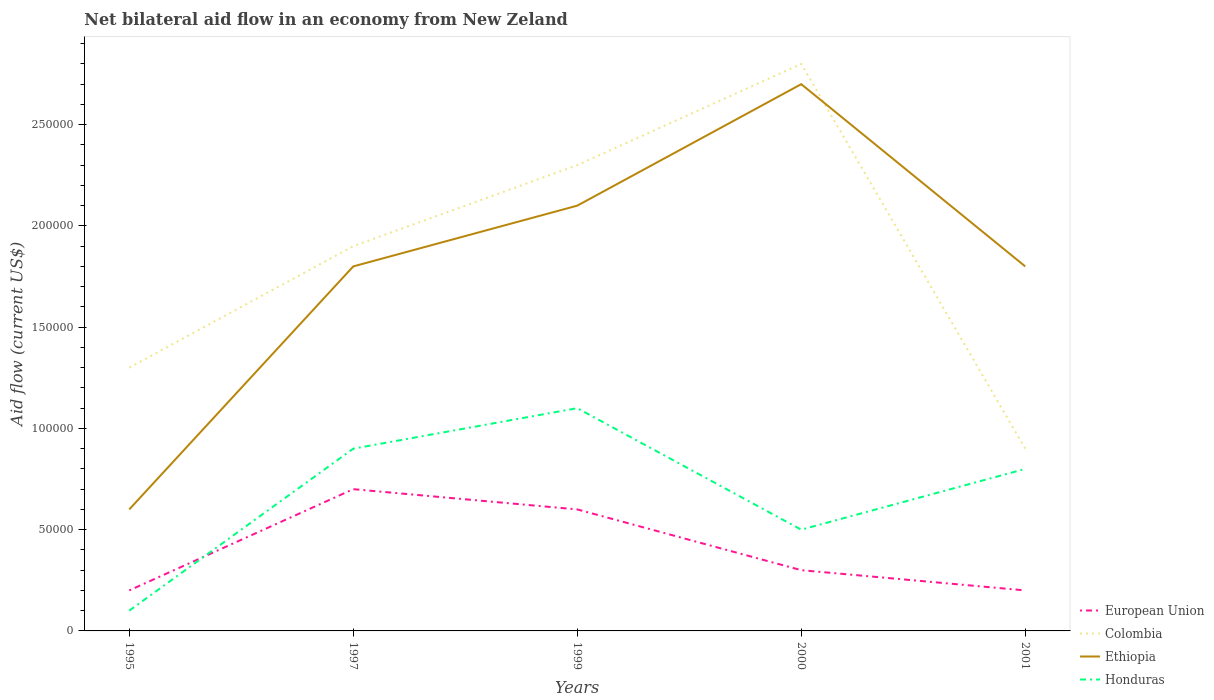What is the difference between the highest and the lowest net bilateral aid flow in Colombia?
Make the answer very short. 3. Is the net bilateral aid flow in Colombia strictly greater than the net bilateral aid flow in European Union over the years?
Your answer should be very brief. No. What is the difference between two consecutive major ticks on the Y-axis?
Keep it short and to the point. 5.00e+04. Does the graph contain any zero values?
Make the answer very short. No. What is the title of the graph?
Your answer should be very brief. Net bilateral aid flow in an economy from New Zeland. Does "Tunisia" appear as one of the legend labels in the graph?
Ensure brevity in your answer.  No. What is the label or title of the Y-axis?
Offer a terse response. Aid flow (current US$). What is the Aid flow (current US$) in European Union in 1995?
Offer a terse response. 2.00e+04. What is the Aid flow (current US$) of Colombia in 1995?
Offer a very short reply. 1.30e+05. What is the Aid flow (current US$) in Ethiopia in 1995?
Keep it short and to the point. 6.00e+04. What is the Aid flow (current US$) in Honduras in 1997?
Offer a very short reply. 9.00e+04. What is the Aid flow (current US$) in Colombia in 1999?
Provide a short and direct response. 2.30e+05. What is the Aid flow (current US$) of Ethiopia in 1999?
Offer a very short reply. 2.10e+05. What is the Aid flow (current US$) in Ethiopia in 2000?
Ensure brevity in your answer.  2.70e+05. What is the Aid flow (current US$) of Honduras in 2000?
Provide a succinct answer. 5.00e+04. What is the Aid flow (current US$) in European Union in 2001?
Offer a terse response. 2.00e+04. Across all years, what is the maximum Aid flow (current US$) of Ethiopia?
Provide a succinct answer. 2.70e+05. Across all years, what is the maximum Aid flow (current US$) of Honduras?
Your answer should be compact. 1.10e+05. Across all years, what is the minimum Aid flow (current US$) of Ethiopia?
Your answer should be compact. 6.00e+04. What is the total Aid flow (current US$) in Colombia in the graph?
Ensure brevity in your answer.  9.20e+05. What is the difference between the Aid flow (current US$) of Ethiopia in 1995 and that in 1997?
Your answer should be very brief. -1.20e+05. What is the difference between the Aid flow (current US$) of Honduras in 1995 and that in 1997?
Keep it short and to the point. -8.00e+04. What is the difference between the Aid flow (current US$) of European Union in 1995 and that in 1999?
Give a very brief answer. -4.00e+04. What is the difference between the Aid flow (current US$) of Ethiopia in 1995 and that in 1999?
Make the answer very short. -1.50e+05. What is the difference between the Aid flow (current US$) in Colombia in 1995 and that in 2000?
Your answer should be very brief. -1.50e+05. What is the difference between the Aid flow (current US$) in Ethiopia in 1995 and that in 2000?
Provide a succinct answer. -2.10e+05. What is the difference between the Aid flow (current US$) of European Union in 1995 and that in 2001?
Provide a short and direct response. 0. What is the difference between the Aid flow (current US$) in Colombia in 1995 and that in 2001?
Your response must be concise. 4.00e+04. What is the difference between the Aid flow (current US$) in Honduras in 1997 and that in 1999?
Provide a short and direct response. -2.00e+04. What is the difference between the Aid flow (current US$) of European Union in 1997 and that in 2000?
Provide a succinct answer. 4.00e+04. What is the difference between the Aid flow (current US$) in Colombia in 1997 and that in 2000?
Give a very brief answer. -9.00e+04. What is the difference between the Aid flow (current US$) of Ethiopia in 1997 and that in 2000?
Keep it short and to the point. -9.00e+04. What is the difference between the Aid flow (current US$) in Honduras in 1997 and that in 2000?
Your answer should be very brief. 4.00e+04. What is the difference between the Aid flow (current US$) in Ethiopia in 1997 and that in 2001?
Provide a short and direct response. 0. What is the difference between the Aid flow (current US$) of European Union in 1999 and that in 2000?
Your answer should be compact. 3.00e+04. What is the difference between the Aid flow (current US$) in Colombia in 1999 and that in 2000?
Your answer should be very brief. -5.00e+04. What is the difference between the Aid flow (current US$) in Ethiopia in 1999 and that in 2000?
Give a very brief answer. -6.00e+04. What is the difference between the Aid flow (current US$) of Honduras in 1999 and that in 2000?
Your answer should be very brief. 6.00e+04. What is the difference between the Aid flow (current US$) of European Union in 1999 and that in 2001?
Your response must be concise. 4.00e+04. What is the difference between the Aid flow (current US$) in Colombia in 1999 and that in 2001?
Provide a short and direct response. 1.40e+05. What is the difference between the Aid flow (current US$) of Honduras in 1999 and that in 2001?
Make the answer very short. 3.00e+04. What is the difference between the Aid flow (current US$) of European Union in 2000 and that in 2001?
Offer a very short reply. 10000. What is the difference between the Aid flow (current US$) in Ethiopia in 2000 and that in 2001?
Your answer should be very brief. 9.00e+04. What is the difference between the Aid flow (current US$) in Honduras in 2000 and that in 2001?
Offer a terse response. -3.00e+04. What is the difference between the Aid flow (current US$) in European Union in 1995 and the Aid flow (current US$) in Colombia in 1997?
Keep it short and to the point. -1.70e+05. What is the difference between the Aid flow (current US$) of European Union in 1995 and the Aid flow (current US$) of Colombia in 1999?
Keep it short and to the point. -2.10e+05. What is the difference between the Aid flow (current US$) of European Union in 1995 and the Aid flow (current US$) of Honduras in 1999?
Provide a succinct answer. -9.00e+04. What is the difference between the Aid flow (current US$) in Colombia in 1995 and the Aid flow (current US$) in Ethiopia in 1999?
Keep it short and to the point. -8.00e+04. What is the difference between the Aid flow (current US$) in Ethiopia in 1995 and the Aid flow (current US$) in Honduras in 1999?
Offer a very short reply. -5.00e+04. What is the difference between the Aid flow (current US$) in European Union in 1995 and the Aid flow (current US$) in Ethiopia in 2000?
Give a very brief answer. -2.50e+05. What is the difference between the Aid flow (current US$) in Ethiopia in 1995 and the Aid flow (current US$) in Honduras in 2000?
Ensure brevity in your answer.  10000. What is the difference between the Aid flow (current US$) of European Union in 1995 and the Aid flow (current US$) of Colombia in 2001?
Your answer should be very brief. -7.00e+04. What is the difference between the Aid flow (current US$) of European Union in 1995 and the Aid flow (current US$) of Honduras in 2001?
Your response must be concise. -6.00e+04. What is the difference between the Aid flow (current US$) of Colombia in 1995 and the Aid flow (current US$) of Honduras in 2001?
Your answer should be compact. 5.00e+04. What is the difference between the Aid flow (current US$) of European Union in 1997 and the Aid flow (current US$) of Colombia in 1999?
Provide a succinct answer. -1.60e+05. What is the difference between the Aid flow (current US$) in European Union in 1997 and the Aid flow (current US$) in Ethiopia in 1999?
Your answer should be compact. -1.40e+05. What is the difference between the Aid flow (current US$) of Colombia in 1997 and the Aid flow (current US$) of Ethiopia in 1999?
Your answer should be compact. -2.00e+04. What is the difference between the Aid flow (current US$) in Colombia in 1997 and the Aid flow (current US$) in Honduras in 1999?
Provide a succinct answer. 8.00e+04. What is the difference between the Aid flow (current US$) of Ethiopia in 1997 and the Aid flow (current US$) of Honduras in 1999?
Keep it short and to the point. 7.00e+04. What is the difference between the Aid flow (current US$) in European Union in 1997 and the Aid flow (current US$) in Colombia in 2000?
Give a very brief answer. -2.10e+05. What is the difference between the Aid flow (current US$) in European Union in 1997 and the Aid flow (current US$) in Ethiopia in 2000?
Make the answer very short. -2.00e+05. What is the difference between the Aid flow (current US$) in European Union in 1997 and the Aid flow (current US$) in Honduras in 2000?
Offer a terse response. 2.00e+04. What is the difference between the Aid flow (current US$) in Colombia in 1997 and the Aid flow (current US$) in Ethiopia in 2000?
Your answer should be very brief. -8.00e+04. What is the difference between the Aid flow (current US$) in European Union in 1997 and the Aid flow (current US$) in Colombia in 2001?
Your answer should be very brief. -2.00e+04. What is the difference between the Aid flow (current US$) in European Union in 1997 and the Aid flow (current US$) in Ethiopia in 2001?
Your answer should be very brief. -1.10e+05. What is the difference between the Aid flow (current US$) of European Union in 1997 and the Aid flow (current US$) of Honduras in 2001?
Provide a succinct answer. -10000. What is the difference between the Aid flow (current US$) in Colombia in 1997 and the Aid flow (current US$) in Ethiopia in 2001?
Offer a very short reply. 10000. What is the difference between the Aid flow (current US$) in European Union in 1999 and the Aid flow (current US$) in Ethiopia in 2000?
Your answer should be compact. -2.10e+05. What is the difference between the Aid flow (current US$) in European Union in 1999 and the Aid flow (current US$) in Honduras in 2000?
Provide a succinct answer. 10000. What is the difference between the Aid flow (current US$) in Colombia in 1999 and the Aid flow (current US$) in Honduras in 2000?
Your answer should be compact. 1.80e+05. What is the difference between the Aid flow (current US$) of European Union in 1999 and the Aid flow (current US$) of Honduras in 2001?
Keep it short and to the point. -2.00e+04. What is the difference between the Aid flow (current US$) of Ethiopia in 1999 and the Aid flow (current US$) of Honduras in 2001?
Provide a succinct answer. 1.30e+05. What is the difference between the Aid flow (current US$) of European Union in 2000 and the Aid flow (current US$) of Colombia in 2001?
Your response must be concise. -6.00e+04. What is the difference between the Aid flow (current US$) of Colombia in 2000 and the Aid flow (current US$) of Honduras in 2001?
Your answer should be compact. 2.00e+05. What is the difference between the Aid flow (current US$) of Ethiopia in 2000 and the Aid flow (current US$) of Honduras in 2001?
Your answer should be compact. 1.90e+05. What is the average Aid flow (current US$) of Colombia per year?
Offer a very short reply. 1.84e+05. What is the average Aid flow (current US$) of Honduras per year?
Provide a succinct answer. 6.80e+04. In the year 1995, what is the difference between the Aid flow (current US$) in European Union and Aid flow (current US$) in Colombia?
Make the answer very short. -1.10e+05. In the year 1995, what is the difference between the Aid flow (current US$) of European Union and Aid flow (current US$) of Ethiopia?
Your response must be concise. -4.00e+04. In the year 1995, what is the difference between the Aid flow (current US$) of Colombia and Aid flow (current US$) of Ethiopia?
Provide a succinct answer. 7.00e+04. In the year 1995, what is the difference between the Aid flow (current US$) of Colombia and Aid flow (current US$) of Honduras?
Give a very brief answer. 1.20e+05. In the year 1995, what is the difference between the Aid flow (current US$) of Ethiopia and Aid flow (current US$) of Honduras?
Ensure brevity in your answer.  5.00e+04. In the year 1997, what is the difference between the Aid flow (current US$) of European Union and Aid flow (current US$) of Colombia?
Make the answer very short. -1.20e+05. In the year 1997, what is the difference between the Aid flow (current US$) in European Union and Aid flow (current US$) in Honduras?
Give a very brief answer. -2.00e+04. In the year 1997, what is the difference between the Aid flow (current US$) in Colombia and Aid flow (current US$) in Honduras?
Your answer should be compact. 1.00e+05. In the year 1997, what is the difference between the Aid flow (current US$) in Ethiopia and Aid flow (current US$) in Honduras?
Ensure brevity in your answer.  9.00e+04. In the year 1999, what is the difference between the Aid flow (current US$) of Colombia and Aid flow (current US$) of Ethiopia?
Provide a succinct answer. 2.00e+04. In the year 1999, what is the difference between the Aid flow (current US$) in Ethiopia and Aid flow (current US$) in Honduras?
Make the answer very short. 1.00e+05. In the year 2000, what is the difference between the Aid flow (current US$) in European Union and Aid flow (current US$) in Honduras?
Provide a short and direct response. -2.00e+04. In the year 2001, what is the difference between the Aid flow (current US$) in European Union and Aid flow (current US$) in Colombia?
Your response must be concise. -7.00e+04. In the year 2001, what is the difference between the Aid flow (current US$) in European Union and Aid flow (current US$) in Ethiopia?
Your response must be concise. -1.60e+05. In the year 2001, what is the difference between the Aid flow (current US$) in Ethiopia and Aid flow (current US$) in Honduras?
Provide a succinct answer. 1.00e+05. What is the ratio of the Aid flow (current US$) in European Union in 1995 to that in 1997?
Your answer should be compact. 0.29. What is the ratio of the Aid flow (current US$) in Colombia in 1995 to that in 1997?
Your answer should be compact. 0.68. What is the ratio of the Aid flow (current US$) of Ethiopia in 1995 to that in 1997?
Your answer should be very brief. 0.33. What is the ratio of the Aid flow (current US$) in Colombia in 1995 to that in 1999?
Give a very brief answer. 0.57. What is the ratio of the Aid flow (current US$) of Ethiopia in 1995 to that in 1999?
Offer a very short reply. 0.29. What is the ratio of the Aid flow (current US$) of Honduras in 1995 to that in 1999?
Keep it short and to the point. 0.09. What is the ratio of the Aid flow (current US$) of Colombia in 1995 to that in 2000?
Provide a short and direct response. 0.46. What is the ratio of the Aid flow (current US$) in Ethiopia in 1995 to that in 2000?
Keep it short and to the point. 0.22. What is the ratio of the Aid flow (current US$) of European Union in 1995 to that in 2001?
Your answer should be compact. 1. What is the ratio of the Aid flow (current US$) of Colombia in 1995 to that in 2001?
Offer a very short reply. 1.44. What is the ratio of the Aid flow (current US$) in European Union in 1997 to that in 1999?
Keep it short and to the point. 1.17. What is the ratio of the Aid flow (current US$) in Colombia in 1997 to that in 1999?
Your answer should be very brief. 0.83. What is the ratio of the Aid flow (current US$) of Ethiopia in 1997 to that in 1999?
Provide a succinct answer. 0.86. What is the ratio of the Aid flow (current US$) of Honduras in 1997 to that in 1999?
Provide a succinct answer. 0.82. What is the ratio of the Aid flow (current US$) of European Union in 1997 to that in 2000?
Your answer should be compact. 2.33. What is the ratio of the Aid flow (current US$) in Colombia in 1997 to that in 2000?
Offer a terse response. 0.68. What is the ratio of the Aid flow (current US$) of Honduras in 1997 to that in 2000?
Your answer should be very brief. 1.8. What is the ratio of the Aid flow (current US$) of Colombia in 1997 to that in 2001?
Offer a terse response. 2.11. What is the ratio of the Aid flow (current US$) in Colombia in 1999 to that in 2000?
Your answer should be very brief. 0.82. What is the ratio of the Aid flow (current US$) of European Union in 1999 to that in 2001?
Make the answer very short. 3. What is the ratio of the Aid flow (current US$) in Colombia in 1999 to that in 2001?
Provide a succinct answer. 2.56. What is the ratio of the Aid flow (current US$) in Honduras in 1999 to that in 2001?
Provide a succinct answer. 1.38. What is the ratio of the Aid flow (current US$) in Colombia in 2000 to that in 2001?
Provide a short and direct response. 3.11. What is the ratio of the Aid flow (current US$) in Honduras in 2000 to that in 2001?
Provide a short and direct response. 0.62. What is the difference between the highest and the second highest Aid flow (current US$) of European Union?
Your response must be concise. 10000. What is the difference between the highest and the second highest Aid flow (current US$) of Colombia?
Provide a short and direct response. 5.00e+04. What is the difference between the highest and the lowest Aid flow (current US$) of European Union?
Provide a succinct answer. 5.00e+04. What is the difference between the highest and the lowest Aid flow (current US$) of Colombia?
Keep it short and to the point. 1.90e+05. What is the difference between the highest and the lowest Aid flow (current US$) in Ethiopia?
Make the answer very short. 2.10e+05. What is the difference between the highest and the lowest Aid flow (current US$) of Honduras?
Keep it short and to the point. 1.00e+05. 